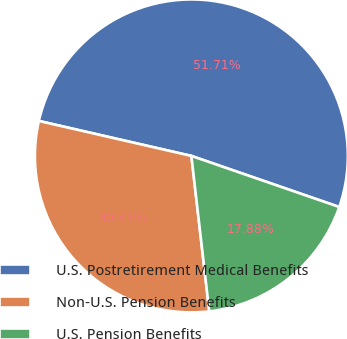<chart> <loc_0><loc_0><loc_500><loc_500><pie_chart><fcel>U.S. Postretirement Medical Benefits<fcel>Non-U.S. Pension Benefits<fcel>U.S. Pension Benefits<nl><fcel>51.7%<fcel>30.41%<fcel>17.88%<nl></chart> 